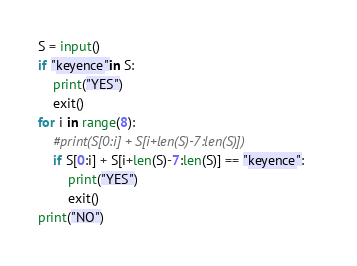<code> <loc_0><loc_0><loc_500><loc_500><_Python_>S = input()
if "keyence"in S:
	print("YES")
	exit()
for i in range(8):
	#print(S[0:i] + S[i+len(S)-7:len(S)])
	if S[0:i] + S[i+len(S)-7:len(S)] == "keyence":	
		print("YES")
		exit()
print("NO")</code> 